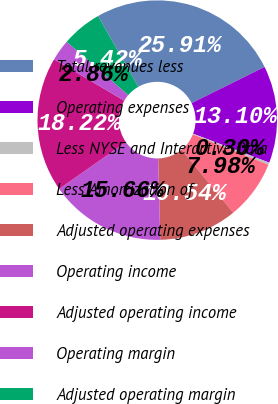Convert chart. <chart><loc_0><loc_0><loc_500><loc_500><pie_chart><fcel>Total revenues less<fcel>Operating expenses<fcel>Less NYSE and Interactive Data<fcel>Less Amortization of<fcel>Adjusted operating expenses<fcel>Operating income<fcel>Adjusted operating income<fcel>Operating margin<fcel>Adjusted operating margin<nl><fcel>25.9%<fcel>13.1%<fcel>0.3%<fcel>7.98%<fcel>10.54%<fcel>15.66%<fcel>18.22%<fcel>2.86%<fcel>5.42%<nl></chart> 